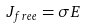Convert formula to latex. <formula><loc_0><loc_0><loc_500><loc_500>J _ { f r e e } = \sigma E</formula> 